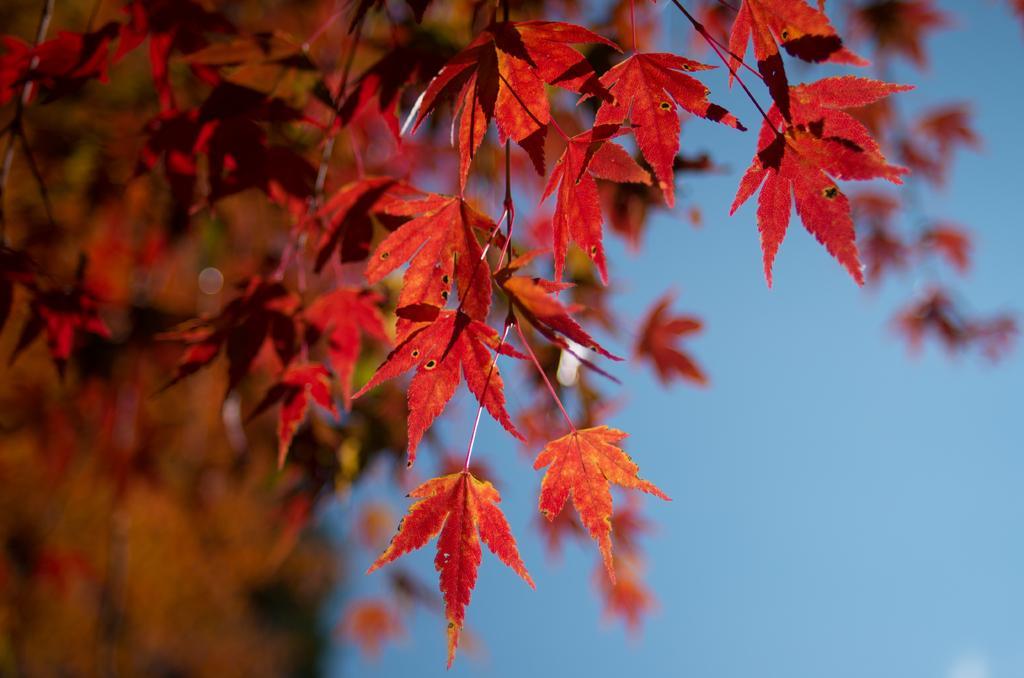Describe this image in one or two sentences. In this image we can see red color leaves and sky. 